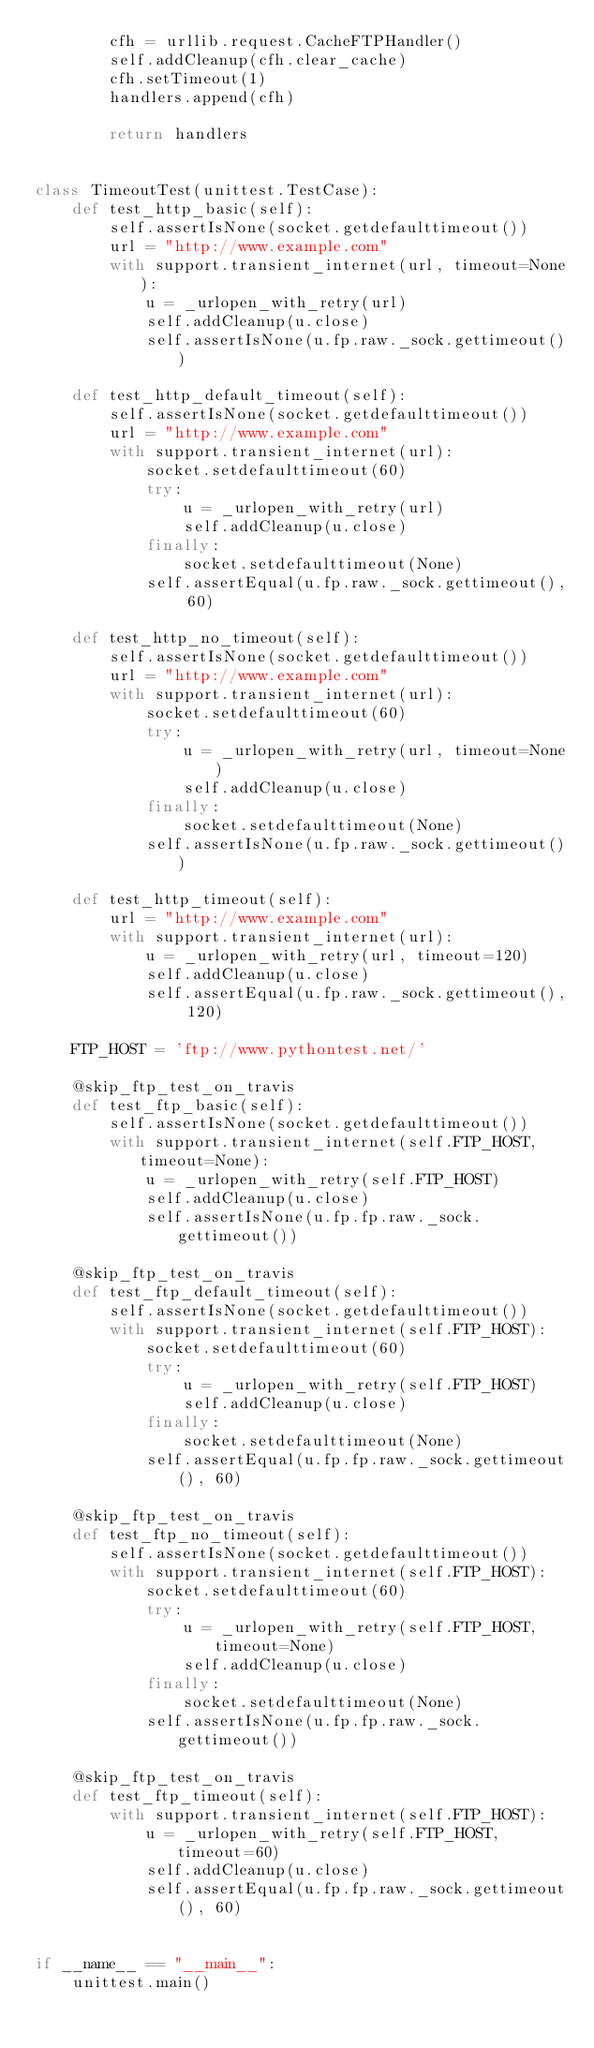<code> <loc_0><loc_0><loc_500><loc_500><_Python_>        cfh = urllib.request.CacheFTPHandler()
        self.addCleanup(cfh.clear_cache)
        cfh.setTimeout(1)
        handlers.append(cfh)

        return handlers


class TimeoutTest(unittest.TestCase):
    def test_http_basic(self):
        self.assertIsNone(socket.getdefaulttimeout())
        url = "http://www.example.com"
        with support.transient_internet(url, timeout=None):
            u = _urlopen_with_retry(url)
            self.addCleanup(u.close)
            self.assertIsNone(u.fp.raw._sock.gettimeout())

    def test_http_default_timeout(self):
        self.assertIsNone(socket.getdefaulttimeout())
        url = "http://www.example.com"
        with support.transient_internet(url):
            socket.setdefaulttimeout(60)
            try:
                u = _urlopen_with_retry(url)
                self.addCleanup(u.close)
            finally:
                socket.setdefaulttimeout(None)
            self.assertEqual(u.fp.raw._sock.gettimeout(), 60)

    def test_http_no_timeout(self):
        self.assertIsNone(socket.getdefaulttimeout())
        url = "http://www.example.com"
        with support.transient_internet(url):
            socket.setdefaulttimeout(60)
            try:
                u = _urlopen_with_retry(url, timeout=None)
                self.addCleanup(u.close)
            finally:
                socket.setdefaulttimeout(None)
            self.assertIsNone(u.fp.raw._sock.gettimeout())

    def test_http_timeout(self):
        url = "http://www.example.com"
        with support.transient_internet(url):
            u = _urlopen_with_retry(url, timeout=120)
            self.addCleanup(u.close)
            self.assertEqual(u.fp.raw._sock.gettimeout(), 120)

    FTP_HOST = 'ftp://www.pythontest.net/'

    @skip_ftp_test_on_travis
    def test_ftp_basic(self):
        self.assertIsNone(socket.getdefaulttimeout())
        with support.transient_internet(self.FTP_HOST, timeout=None):
            u = _urlopen_with_retry(self.FTP_HOST)
            self.addCleanup(u.close)
            self.assertIsNone(u.fp.fp.raw._sock.gettimeout())

    @skip_ftp_test_on_travis
    def test_ftp_default_timeout(self):
        self.assertIsNone(socket.getdefaulttimeout())
        with support.transient_internet(self.FTP_HOST):
            socket.setdefaulttimeout(60)
            try:
                u = _urlopen_with_retry(self.FTP_HOST)
                self.addCleanup(u.close)
            finally:
                socket.setdefaulttimeout(None)
            self.assertEqual(u.fp.fp.raw._sock.gettimeout(), 60)

    @skip_ftp_test_on_travis
    def test_ftp_no_timeout(self):
        self.assertIsNone(socket.getdefaulttimeout())
        with support.transient_internet(self.FTP_HOST):
            socket.setdefaulttimeout(60)
            try:
                u = _urlopen_with_retry(self.FTP_HOST, timeout=None)
                self.addCleanup(u.close)
            finally:
                socket.setdefaulttimeout(None)
            self.assertIsNone(u.fp.fp.raw._sock.gettimeout())

    @skip_ftp_test_on_travis
    def test_ftp_timeout(self):
        with support.transient_internet(self.FTP_HOST):
            u = _urlopen_with_retry(self.FTP_HOST, timeout=60)
            self.addCleanup(u.close)
            self.assertEqual(u.fp.fp.raw._sock.gettimeout(), 60)


if __name__ == "__main__":
    unittest.main()
</code> 